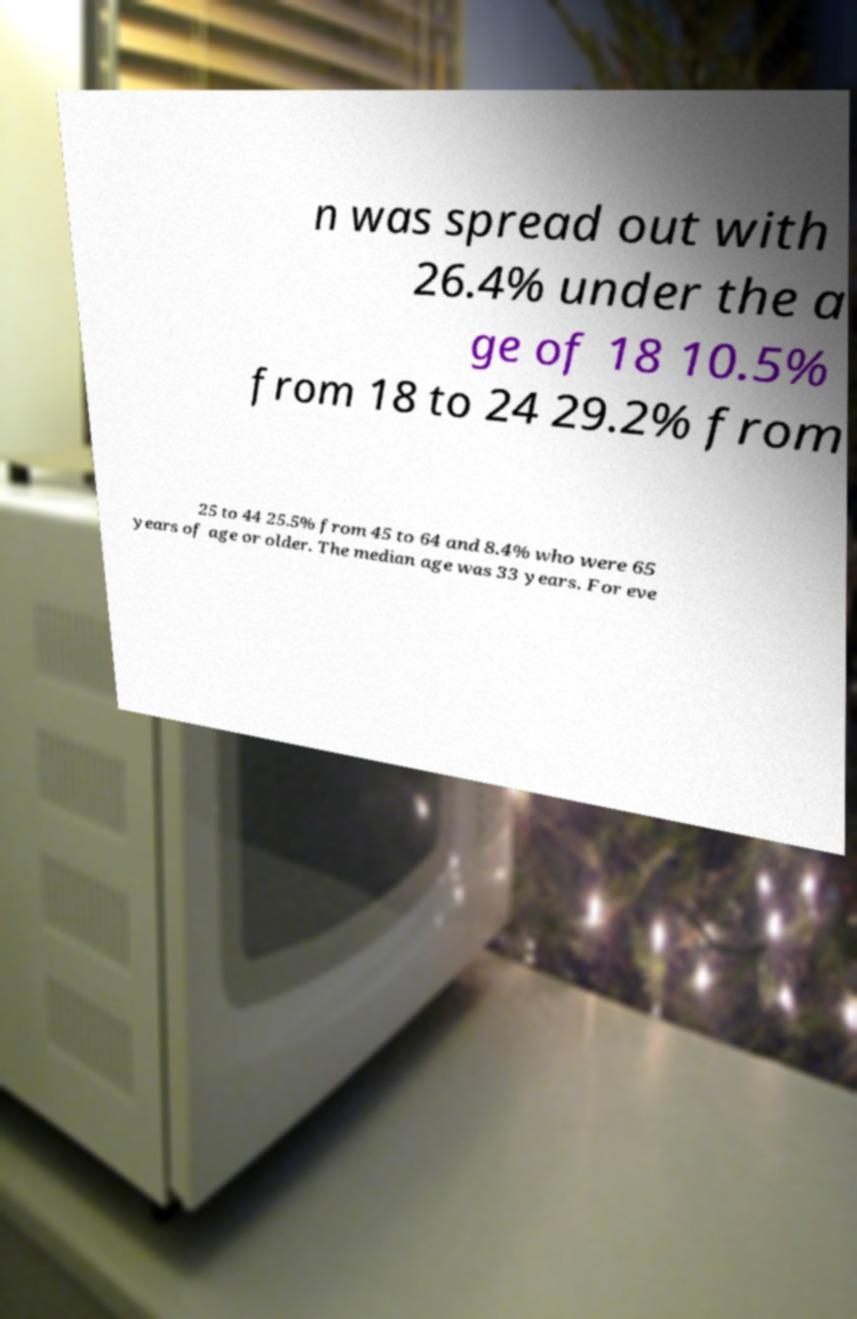For documentation purposes, I need the text within this image transcribed. Could you provide that? n was spread out with 26.4% under the a ge of 18 10.5% from 18 to 24 29.2% from 25 to 44 25.5% from 45 to 64 and 8.4% who were 65 years of age or older. The median age was 33 years. For eve 